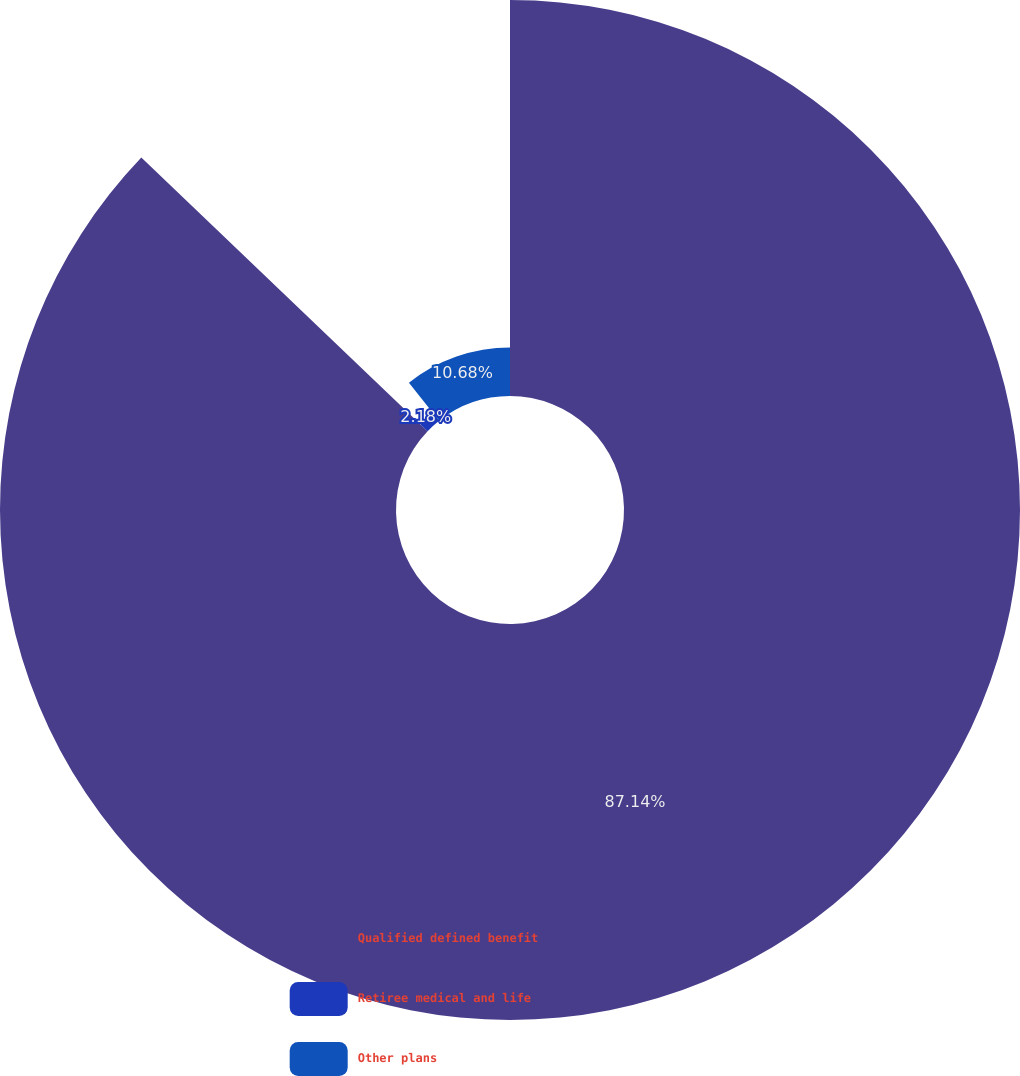<chart> <loc_0><loc_0><loc_500><loc_500><pie_chart><fcel>Qualified defined benefit<fcel>Retiree medical and life<fcel>Other plans<nl><fcel>87.14%<fcel>2.18%<fcel>10.68%<nl></chart> 